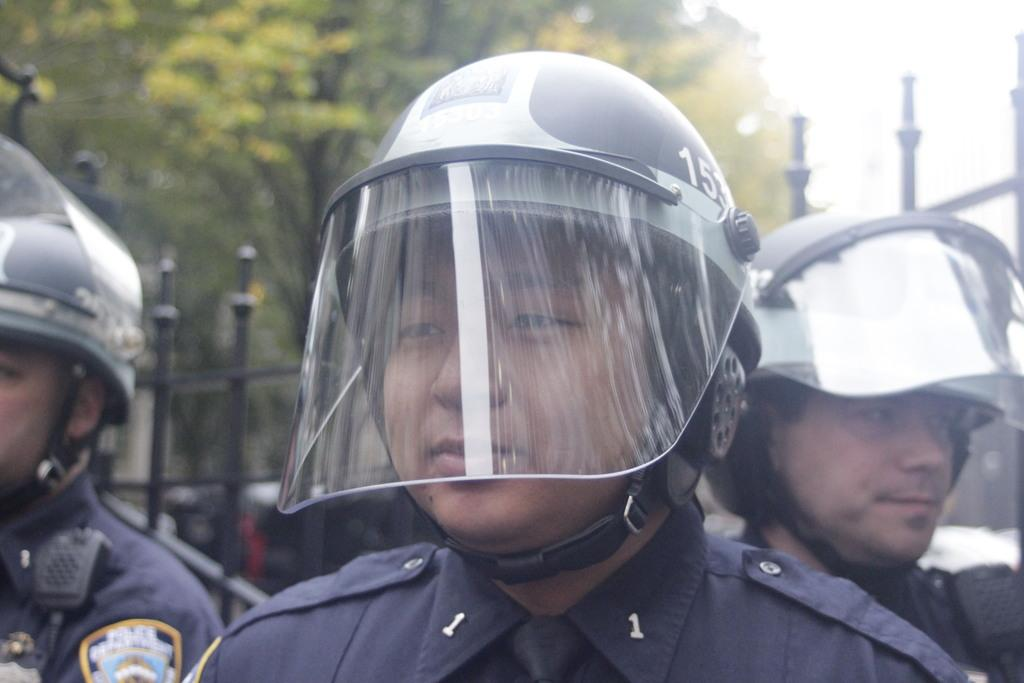How many people are in the image? There are three persons in the image. What are the persons wearing on their heads? The persons are wearing helmets. What can be seen in the background of the image? There is a fence, trees, and the sky visible in the background of the image. What type of party is the governor hosting in the image? There is no party or governor present in the image. 